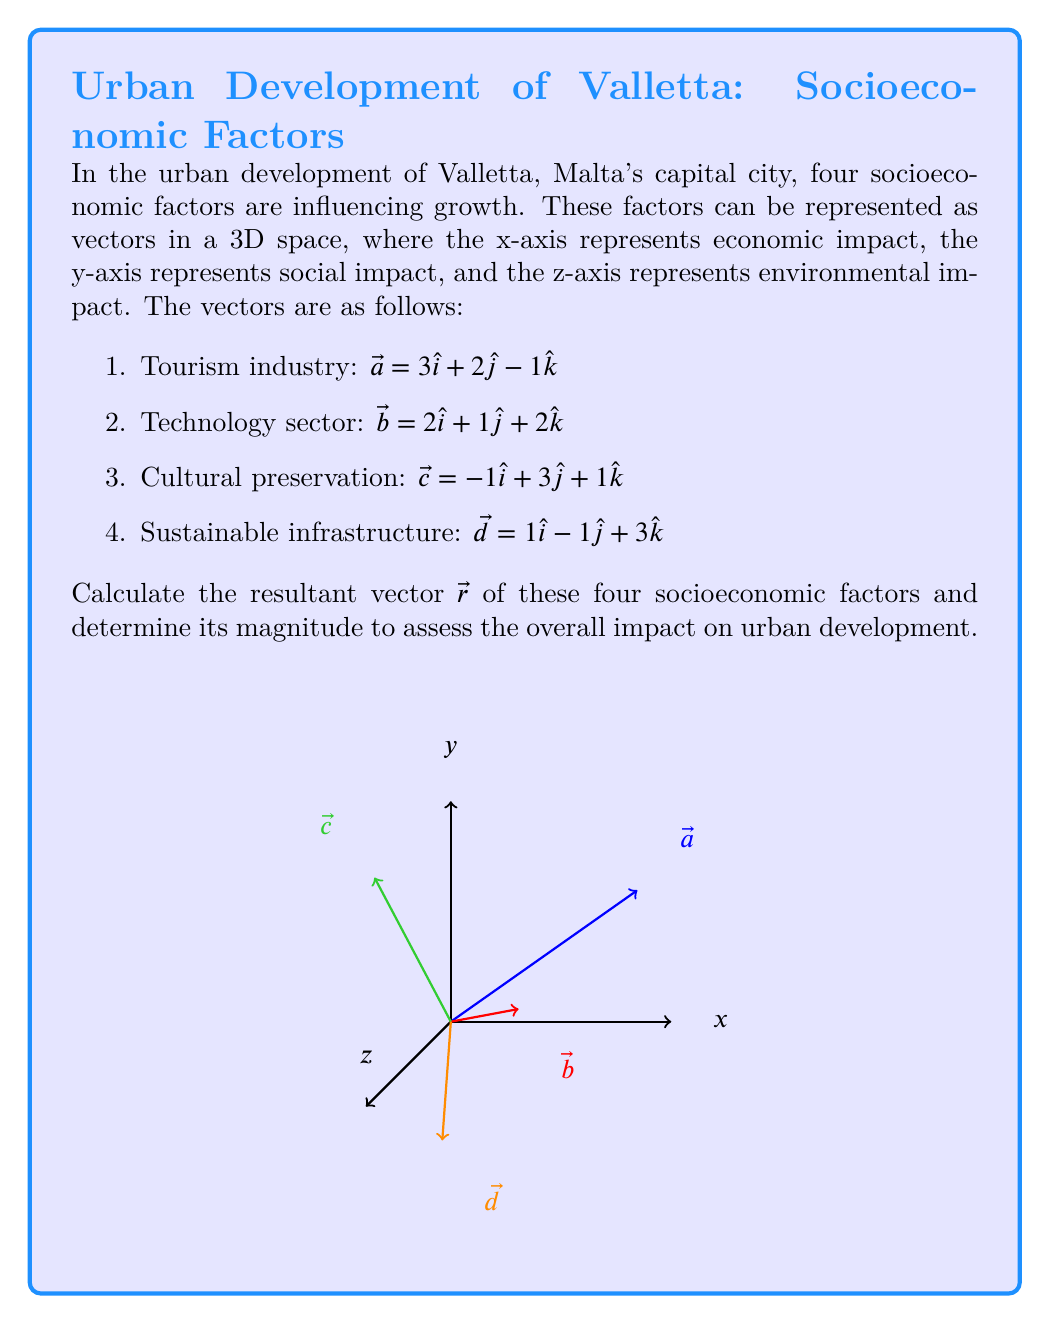Provide a solution to this math problem. To solve this problem, we'll follow these steps:

1) First, we need to add all the vectors to find the resultant vector $\vec{r}$:

   $\vec{r} = \vec{a} + \vec{b} + \vec{c} + \vec{d}$

2) Let's add the components:

   $\vec{r} = (3\hat{i} + 2\hat{j} - 1\hat{k}) + (2\hat{i} + 1\hat{j} + 2\hat{k}) + (-1\hat{i} + 3\hat{j} + 1\hat{k}) + (1\hat{i} - 1\hat{j} + 3\hat{k})$

3) Grouping like terms:

   $\vec{r} = (3+2-1+1)\hat{i} + (2+1+3-1)\hat{j} + (-1+2+1+3)\hat{k}$

4) Simplifying:

   $\vec{r} = 5\hat{i} + 5\hat{j} + 5\hat{k}$

5) To find the magnitude of $\vec{r}$, we use the formula:

   $|\vec{r}| = \sqrt{x^2 + y^2 + z^2}$

   Where x, y, and z are the components of $\vec{r}$.

6) Substituting the values:

   $|\vec{r}| = \sqrt{5^2 + 5^2 + 5^2}$

7) Simplifying:

   $|\vec{r}| = \sqrt{75} = 5\sqrt{3}$

Therefore, the resultant vector $\vec{r} = 5\hat{i} + 5\hat{j} + 5\hat{k}$ with a magnitude of $5\sqrt{3}$.
Answer: $\vec{r} = 5\hat{i} + 5\hat{j} + 5\hat{k}$, $|\vec{r}| = 5\sqrt{3}$ 